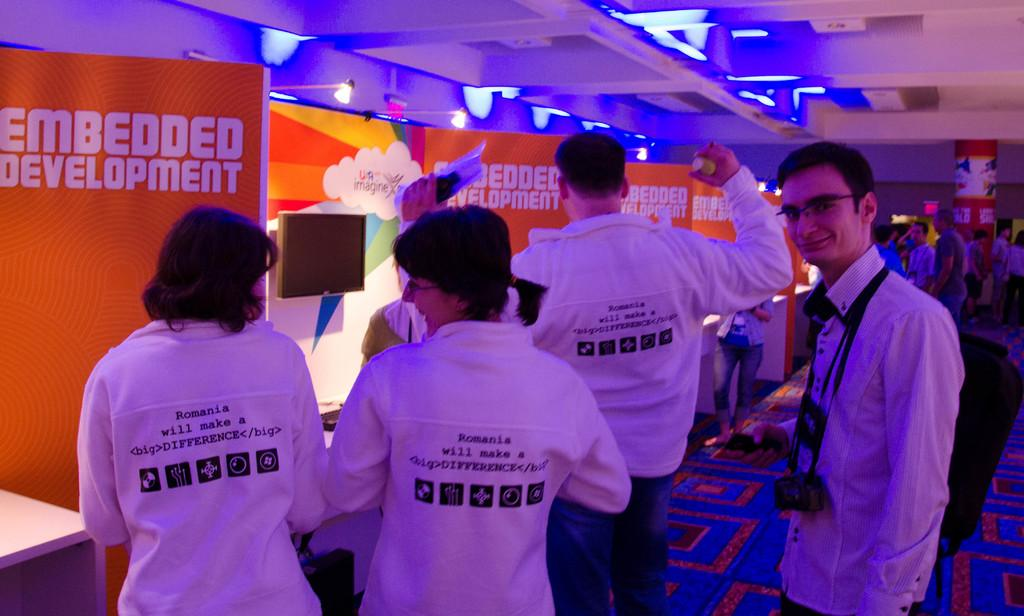What can be seen in the image involving human presence? There are people standing in the image. Where are the people standing? The people are standing on the floor. What else is present in the image besides the people? There are advertisement boards and electric lights visible in the image. Can you see any apples being served by a lawyer in the image? There is no lawyer or apple present in the image. Is there any steam coming from the electric lights in the image? There is no steam visible in the image; only electric lights are present. 